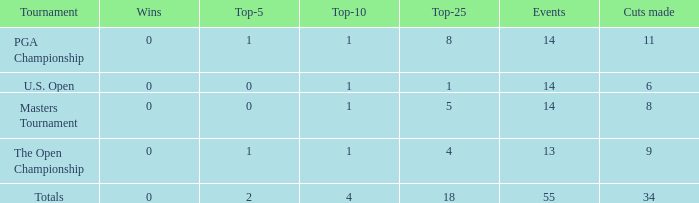What is the sum of wins when events is 13 and top-5 is less than 1? None. 